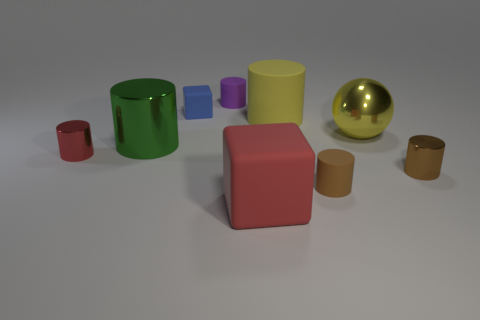Are there any pairs of objects that are similar in color? Yes, the two blue cylinders in the center have similar colors. Can you describe their difference in size? The cylinder on the left is smaller and shorter, while the one on the right is slightly taller and wider. 